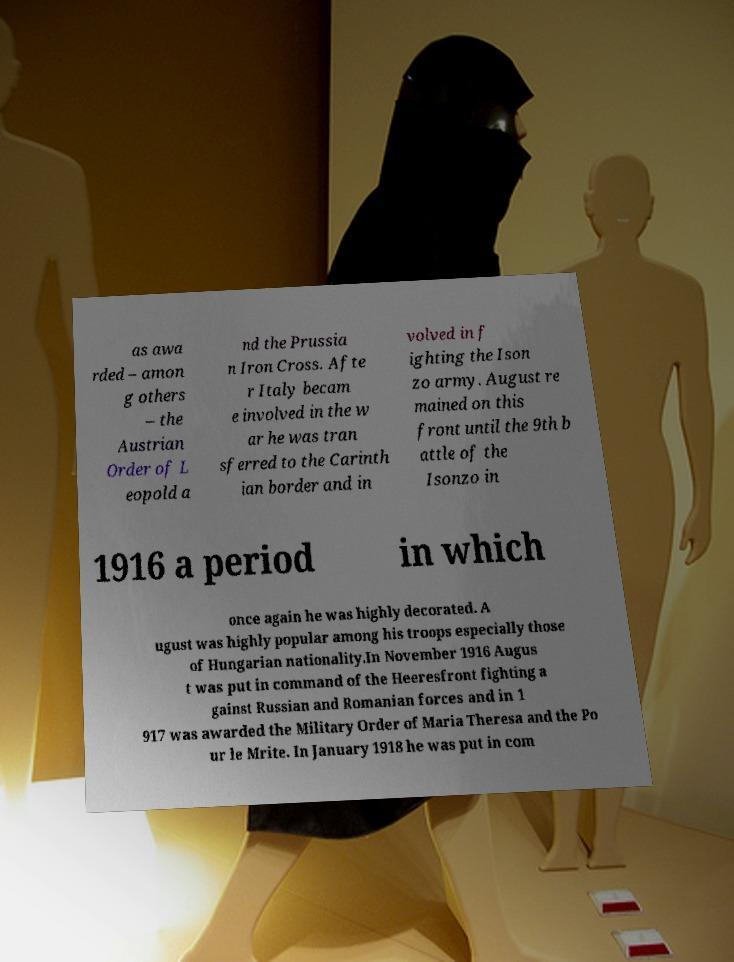What messages or text are displayed in this image? I need them in a readable, typed format. as awa rded – amon g others – the Austrian Order of L eopold a nd the Prussia n Iron Cross. Afte r Italy becam e involved in the w ar he was tran sferred to the Carinth ian border and in volved in f ighting the Ison zo army. August re mained on this front until the 9th b attle of the Isonzo in 1916 a period in which once again he was highly decorated. A ugust was highly popular among his troops especially those of Hungarian nationality.In November 1916 Augus t was put in command of the Heeresfront fighting a gainst Russian and Romanian forces and in 1 917 was awarded the Military Order of Maria Theresa and the Po ur le Mrite. In January 1918 he was put in com 